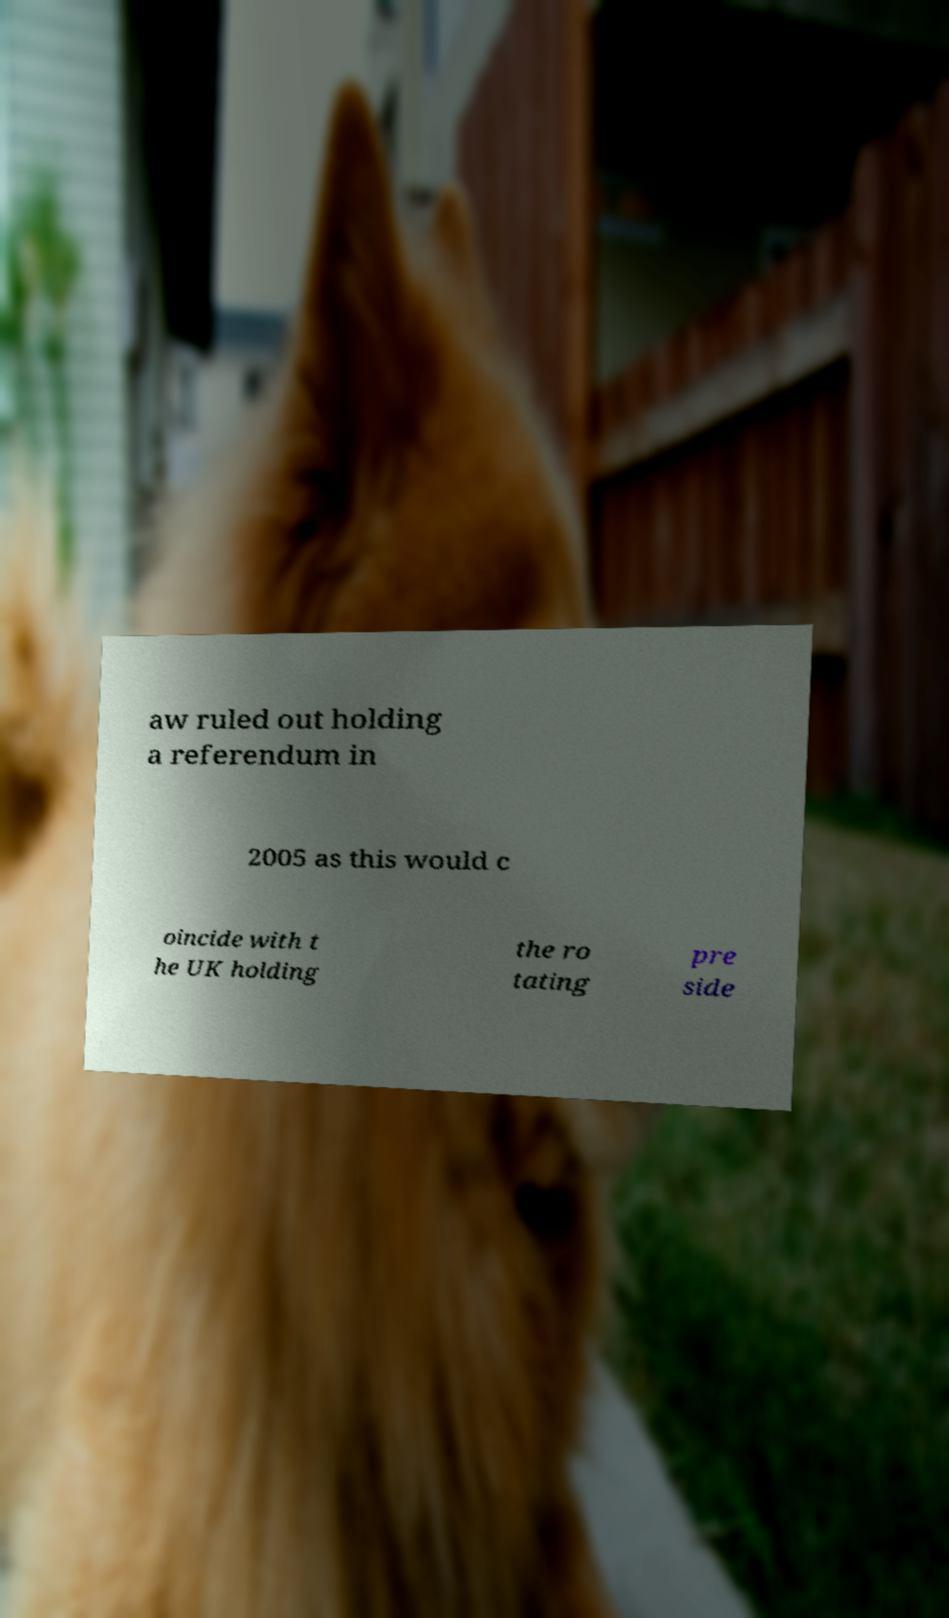What messages or text are displayed in this image? I need them in a readable, typed format. aw ruled out holding a referendum in 2005 as this would c oincide with t he UK holding the ro tating pre side 